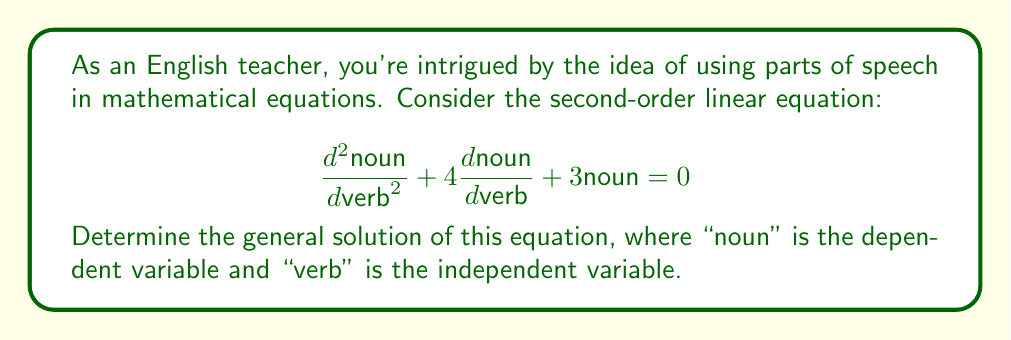What is the answer to this math problem? To solve this second-order linear equation, we'll follow these steps:

1. Identify the characteristic equation:
The characteristic equation for this second-order linear equation is:
$$r^2 + 4r + 3 = 0$$

2. Solve the characteristic equation:
We can factor this equation:
$$(r + 1)(r + 3) = 0$$
So, $r = -1$ or $r = -3$

3. Determine the general solution:
Since we have two distinct real roots, the general solution will be of the form:
$$\text{noun} = c_1e^{r_1\text{verb}} + c_2e^{r_2\text{verb}}$$

Where $r_1 = -1$ and $r_2 = -3$, and $c_1$ and $c_2$ are arbitrary constants.

Substituting these values, we get:
$$\text{noun} = c_1e^{-1\text{verb}} + c_2e^{-3\text{verb}}$$

This is the general solution to the given equation. Note that "noun" represents the dependent variable (typically y in standard notation) and "verb" represents the independent variable (typically x or t in standard notation).
Answer: The general solution is:
$$\text{noun} = c_1e^{-1\text{verb}} + c_2e^{-3\text{verb}}$$
where $c_1$ and $c_2$ are arbitrary constants. 